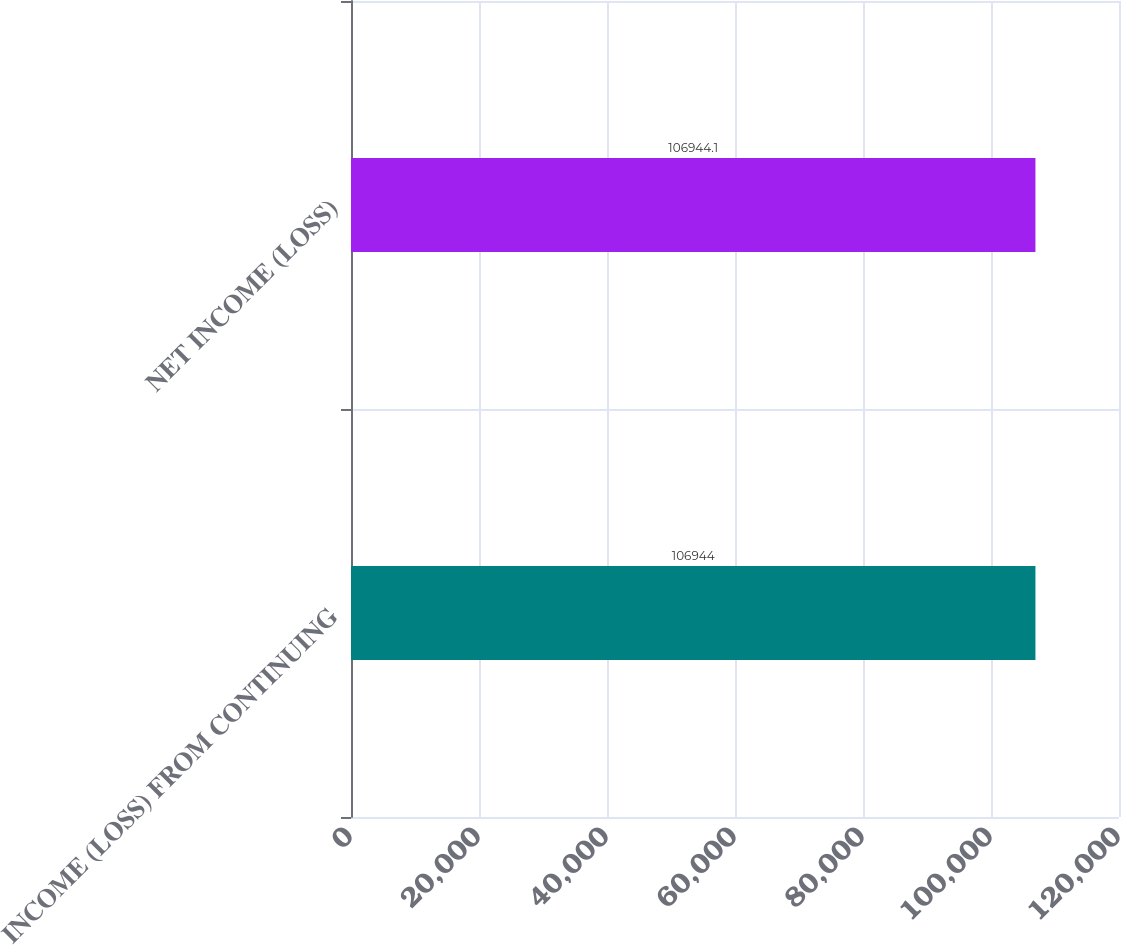Convert chart. <chart><loc_0><loc_0><loc_500><loc_500><bar_chart><fcel>INCOME (LOSS) FROM CONTINUING<fcel>NET INCOME (LOSS)<nl><fcel>106944<fcel>106944<nl></chart> 